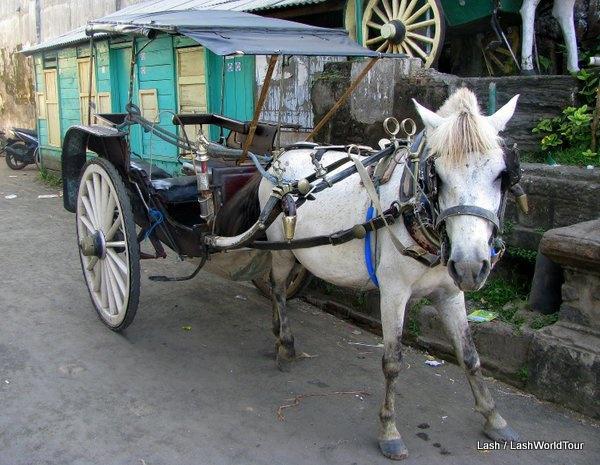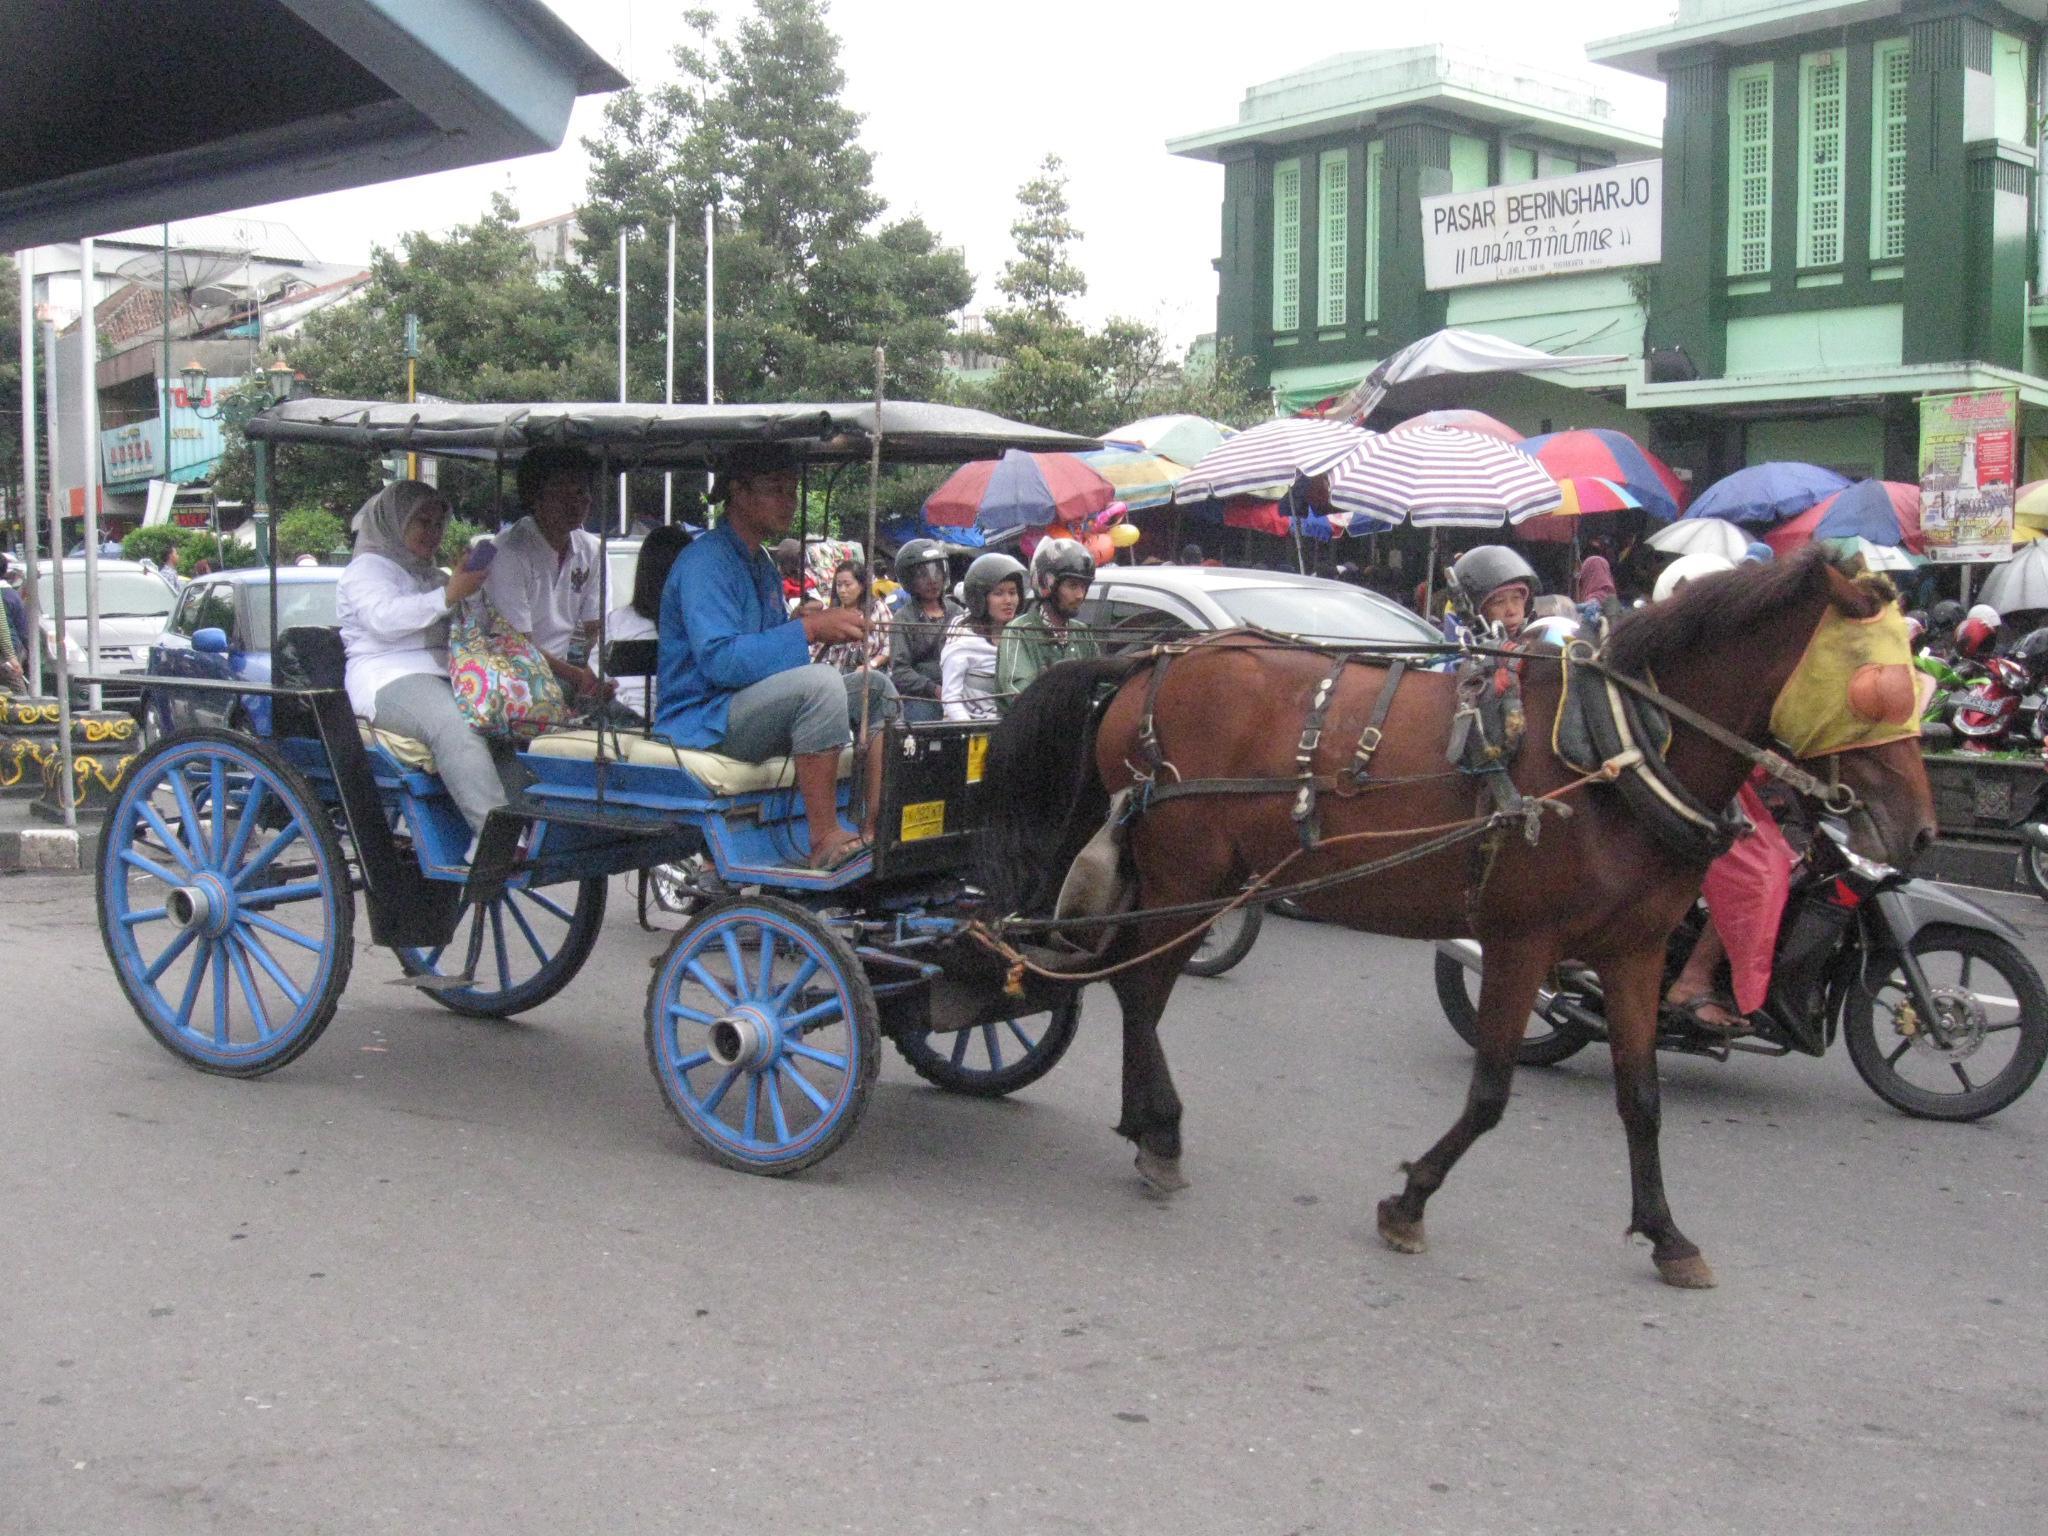The first image is the image on the left, the second image is the image on the right. Assess this claim about the two images: "The left and right image contains the same number of horses pulling a cart.". Correct or not? Answer yes or no. Yes. The first image is the image on the left, the second image is the image on the right. Considering the images on both sides, is "An image shows a leftward-turned horse standing still with lowered head and hitched to a two-wheeled cart with a canopy top." valid? Answer yes or no. No. 